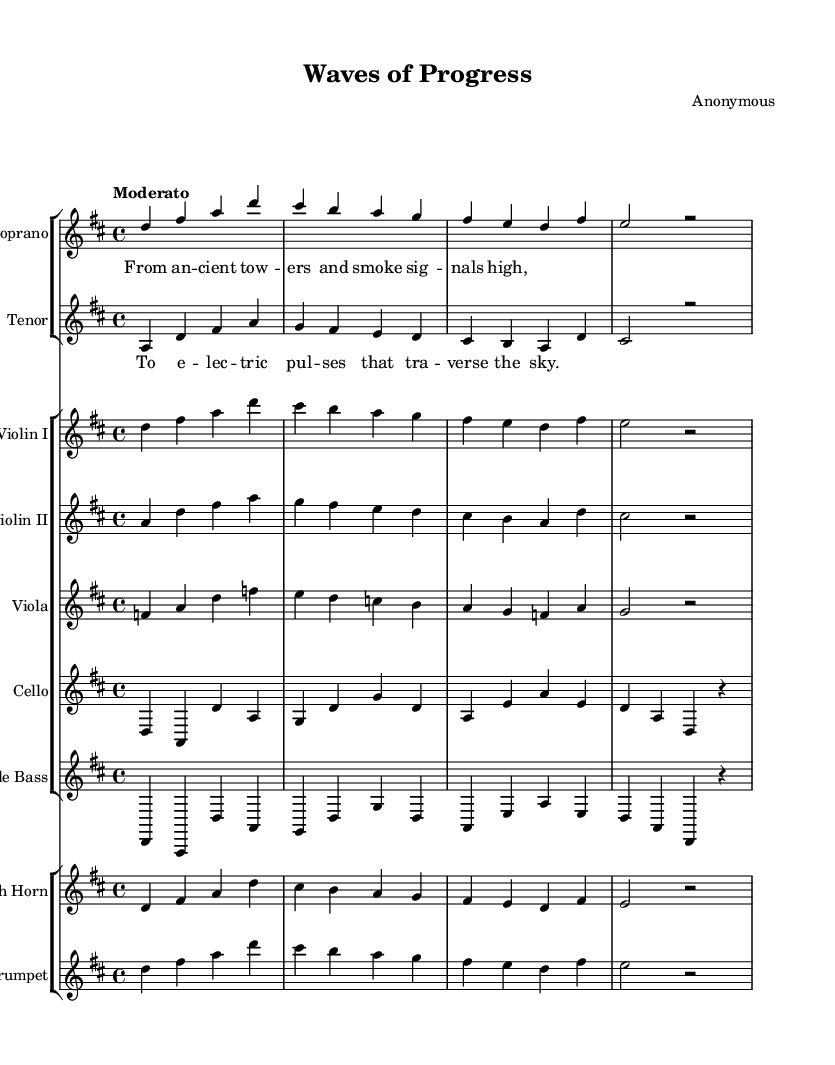What is the key signature of this music? The key signature is indicated at the beginning of the staff with two sharps, which corresponds to D major.
Answer: D major What is the time signature used in this piece? The time signature is noted at the beginning with a "4/4", indicating four beats per measure, with a quarter note receiving one beat.
Answer: 4/4 What is the tempo marking for this piece? The tempo marking is given as "Moderato", which indicates a moderate pace of speed for the performance.
Answer: Moderato How many instruments are featured in this score? There are a total of 9 instruments, counting both vocal parts and instrument groups (soprano, tenor, violins I & II, viola, cello, double bass, French horn, and trumpet).
Answer: 9 What is the name of this opera? The title of the opera is "Waves of Progress", as indicated in the header section of the sheet music.
Answer: Waves of Progress From which historical signals does the soprano part reference? The soprano lyrics reference "ancient towers and smoke signals," highlighting the beginnings of long-distance communication.
Answer: ancient towers and smoke signals To what modern technology does the tenor part allude? The tenor lyrics refer to "electronic pulses that traverse the sky," pointing to contemporary forms of communication like Wi-Fi.
Answer: electronic pulses 